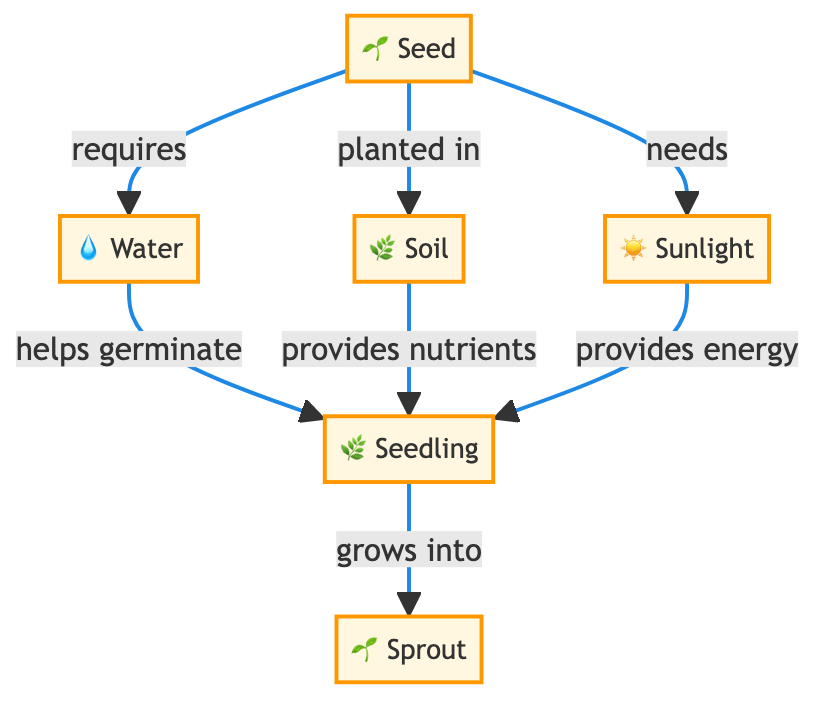What is the starting point of the plant? The diagram shows that the first element is "Seed," which is marked as the starting point of the plant's growth process.
Answer: Seed How many essential elements are needed for the seed? By counting the connections leading from the "Seed" node, we see three: water, soil, and sunlight are all required for the seed.
Answer: 3 What does water help to achieve? The diagram states that water "helps germinate" the seed, leading to the emergence of the seedling.
Answer: Germinate Which element provides energy to the seedling? The connection from "Sunlight" to "Seedling" shows that sunlight is responsible for providing energy necessary for the seedling's growth.
Answer: Sunlight What does the seedling grow into? The diagram directly indicates that the "Seedling" grows into a "Sprout," marking the next stage in development.
Answer: Sprout What does soil provide to the seedling? The connection shows that soil "provides nutrients" to the seedling, which are essential for its growth and development.
Answer: Nutrients How many total nodes are present in this diagram? By counting all the elements in the diagram, including seed, water, soil, sunlight, seedling, and sprout, we find there are six total nodes.
Answer: 6 What relationship exists between soil and seedling? The diagram specifies that soil "provides nutrients" to seedling, indicating a dependency for growth.
Answer: Provides nutrients Which element is required for the seed to germinate? The diagram connects water to seed, indicating the necessity of water for the seed to begin the germination process.
Answer: Water How does sunlight relate to the seedling? The diagram illustrates that sunlight "provides energy" which is crucial for the seedling's growth and development.
Answer: Provides energy 